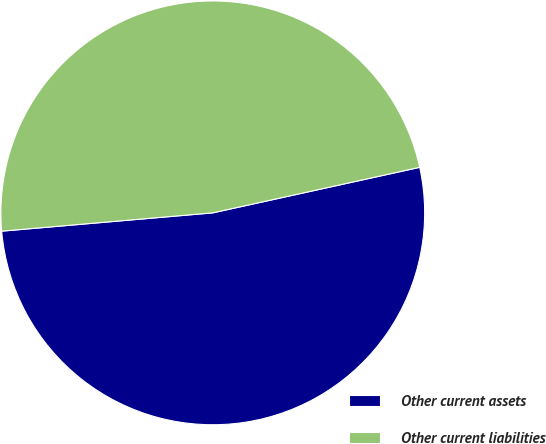Convert chart to OTSL. <chart><loc_0><loc_0><loc_500><loc_500><pie_chart><fcel>Other current assets<fcel>Other current liabilities<nl><fcel>52.07%<fcel>47.93%<nl></chart> 